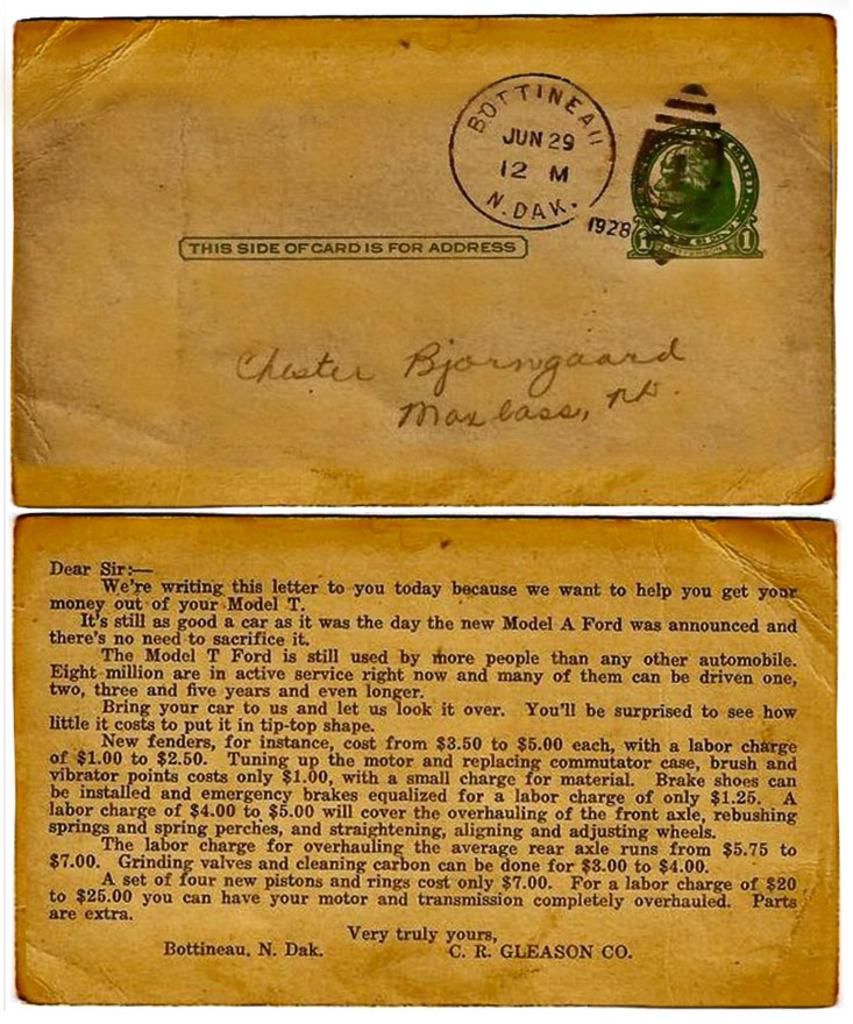<image>
Describe the image concisely. A old letter that is stapped Bottinea jun 29 12 N Dak 